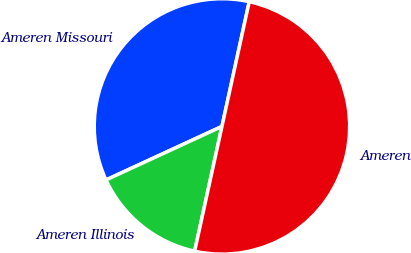Convert chart to OTSL. <chart><loc_0><loc_0><loc_500><loc_500><pie_chart><fcel>Ameren Missouri<fcel>Ameren Illinois<fcel>Ameren<nl><fcel>35.31%<fcel>14.69%<fcel>50.0%<nl></chart> 